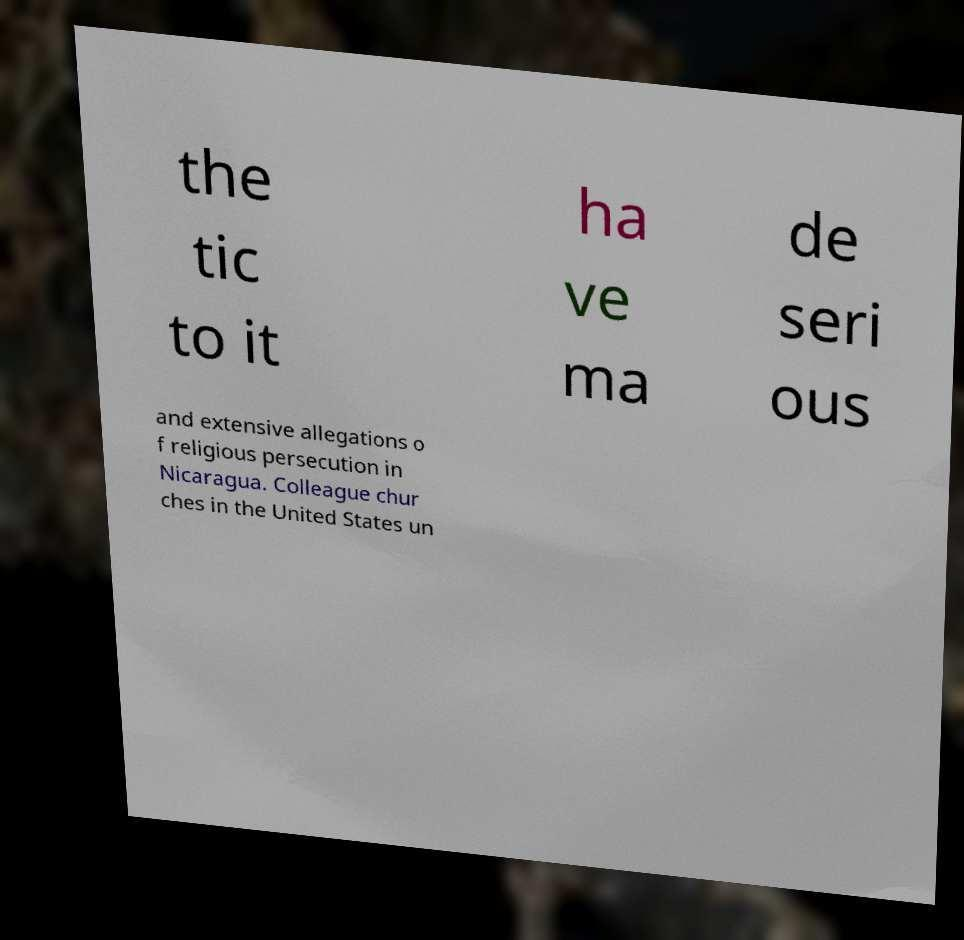Could you extract and type out the text from this image? the tic to it ha ve ma de seri ous and extensive allegations o f religious persecution in Nicaragua. Colleague chur ches in the United States un 